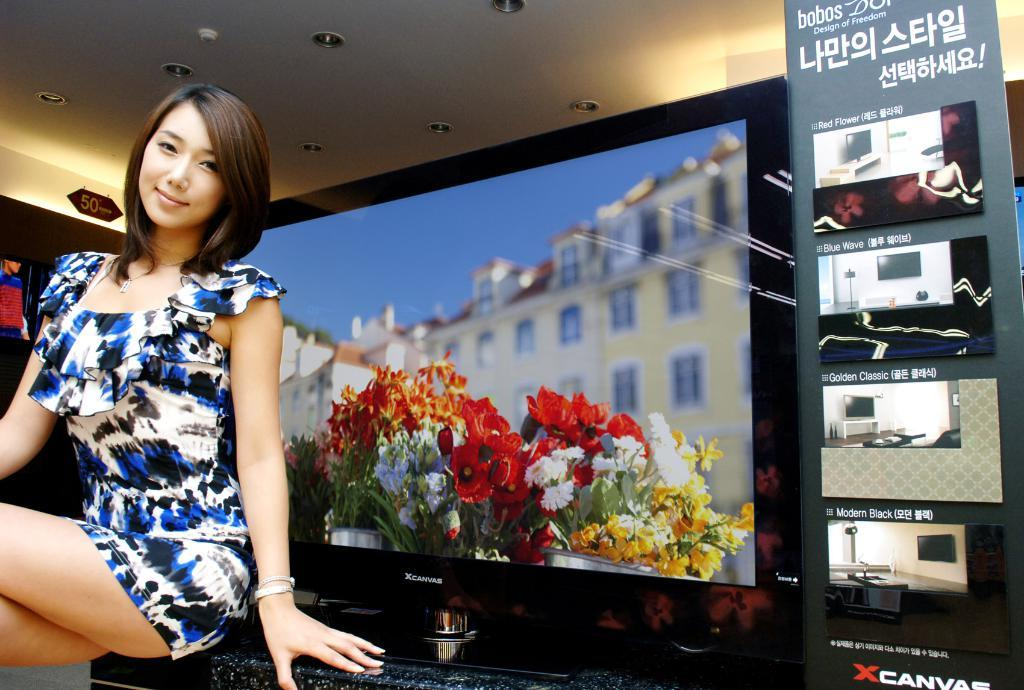<image>
Write a terse but informative summary of the picture. The woman is probably a model for the XCanvas televisions. 